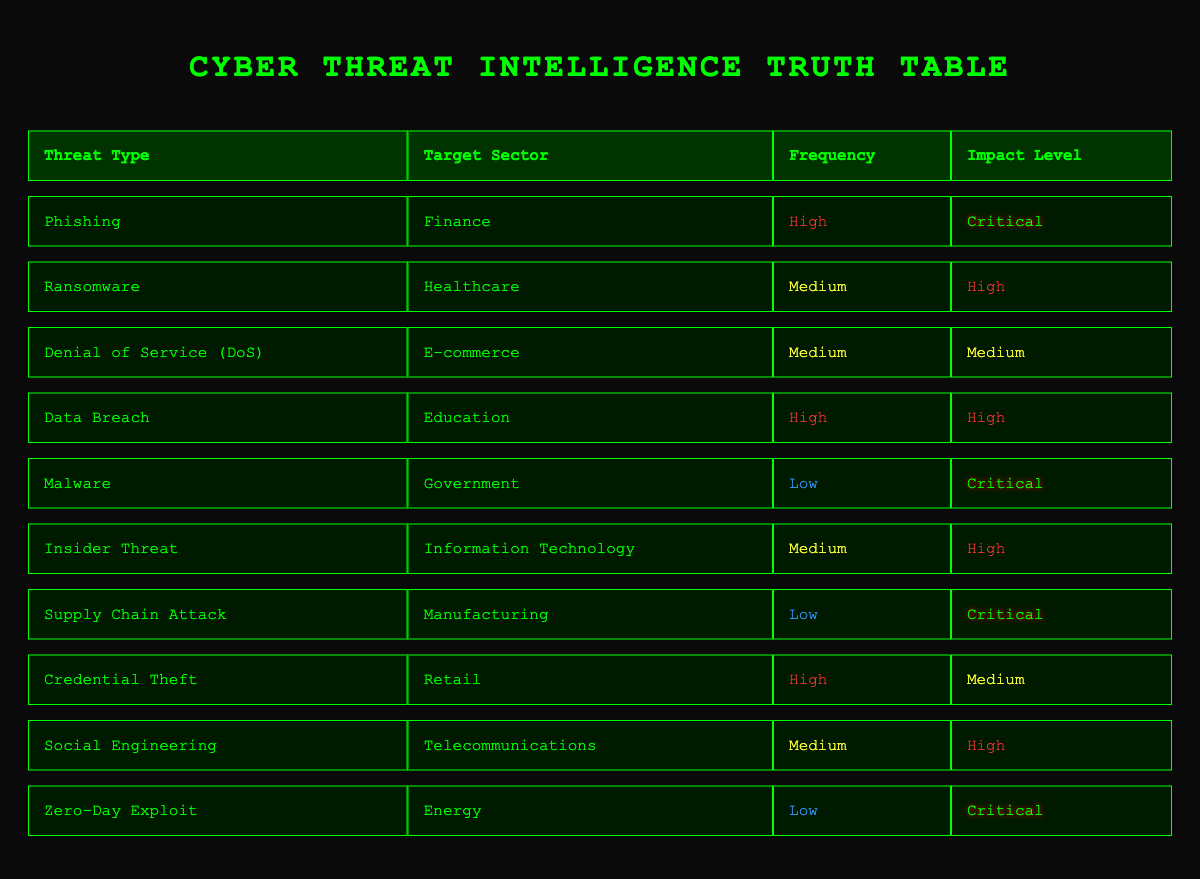What is the most frequent threat type in the finance sector? The table displays "Phishing" under the Threat Type column for the Finance sector and marks its frequency as "High." Since no other threat type is listed for the Finance sector, "Phishing" is the most frequent.
Answer: Phishing How many threat types have a critical impact level? The table indicates that "Phishing," "Malware," "Supply Chain Attack," and "Zero-Day Exploit" are categorized with a critical impact level. Therefore, by counting these entries, we find there are 4 threat types with a critical impact level.
Answer: 4 Is "Data Breach" marked with a high frequency? Looking at the table, "Data Breach" has a frequency marked as "High." Therefore, the answer to whether it is marked with high frequency is true.
Answer: Yes Which target sector is associated with the medium frequency and high impact level? By reviewing the table, the "Insider Threat" in the Information Technology sector is listed as "Medium" in frequency and "High" in impact level, indicating that this is a case that meets both criteria.
Answer: Information Technology What is the total number of threat types listed in the healthcare sector? The table shows only one entry for the healthcare sector, which is "Ransomware." Hence, the total number of threat types listed for this sector is 1.
Answer: 1 How many of the listed threat types are categorized as having a low frequency? Referring to the table, "Malware," "Supply Chain Attack," and "Zero-Day Exploit" are the three threat types marked as "Low" in frequency. Counting these gives a total of 3 threat types with a low frequency.
Answer: 3 Is there a threat type related to telecommunications with high impact? The table indicates that "Social Engineering," targeting the Telecommunications sector, has a "High" impact level. This means there is indeed a threat type related to telecommunications with high impact.
Answer: Yes Which threat type appears in the e-commerce sector and how is its impact level classified? The table lists "Denial of Service (DoS)" under the threat types for the e-commerce sector, with its impact level categorized as "Medium." Thus, the answer reveals both the threat type and its impact classification.
Answer: Denial of Service (DoS), Medium 